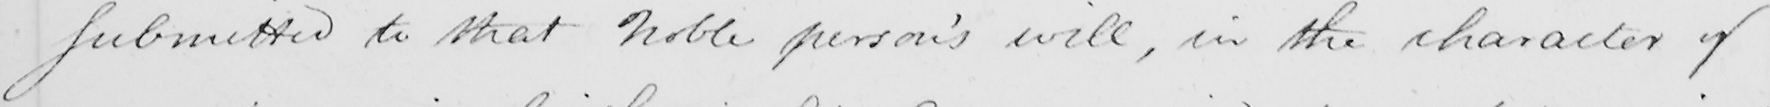What does this handwritten line say? submitted to that Noble person ' s will , in the character of 